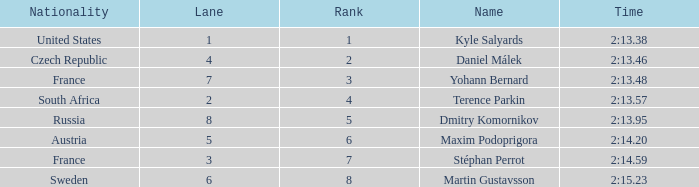What was Stéphan Perrot rank average? 7.0. 